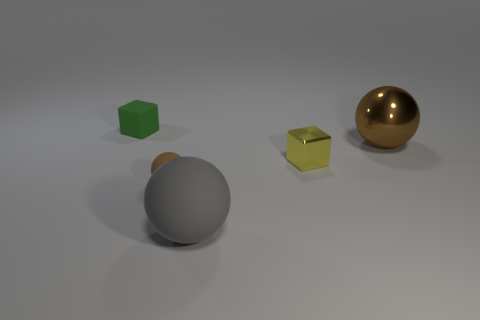What number of other things are there of the same size as the gray object? Including the gray object, there's one golden sphere that appears to be of similar size. 